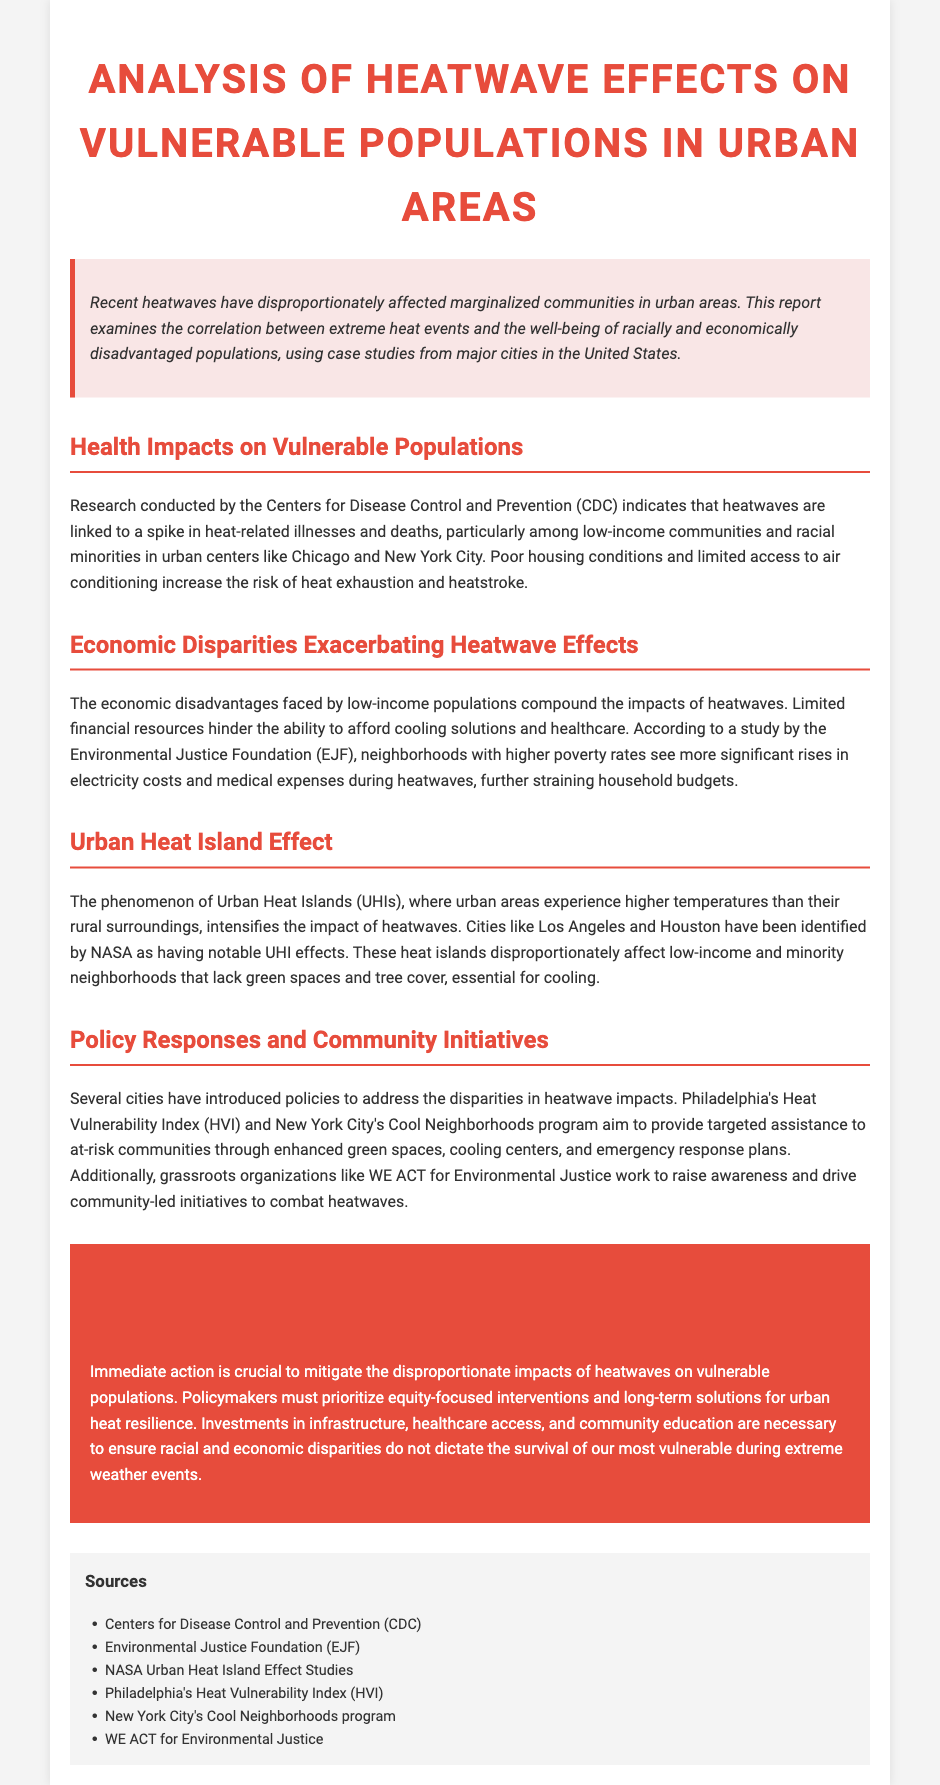What is the title of the report? The title is centered and prominent in the document, stating the focus of the analysis.
Answer: Analysis of Heatwave Effects on Vulnerable Populations in Urban Areas Which organization conducted the research on health impacts? The document mentions the sponsoring organization responsible for the health impact research.
Answer: Centers for Disease Control and Prevention (CDC) What phenomenon intensifies the impact of heatwaves in urban areas? The report highlights a specific phenomenon affecting temperature variations in urban environments.
Answer: Urban Heat Island Effect What does the acronym HVI stand for? The document refers to a specific policy response aimed at addressing heat vulnerability.
Answer: Heat Vulnerability Index Which city has a program called "Cool Neighborhoods"? The document discusses a specific city that has implemented a program aimed at combating heat effects.
Answer: New York City How do limited financial resources affect low-income populations during heatwaves? According to the report, the economic disadvantage has specific consequences during extreme weather events.
Answer: Hinder the ability to afford cooling solutions and healthcare What is a significant factor that increases heat-related illness and deaths? The report connects specific conditions faced by vulnerable populations to health risks during heatwaves.
Answer: Poor housing conditions What organizations are mentioned as working in the community initiatives section? The report lists grassroots organizations that focus on driving community-led efforts to combat heat impacts.
Answer: WE ACT for Environmental Justice 